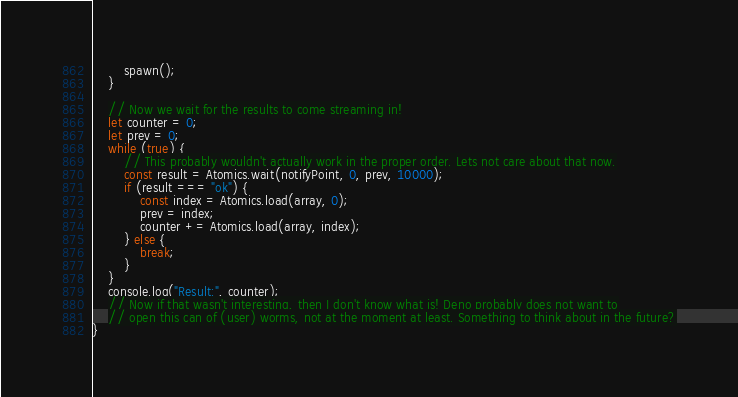Convert code to text. <code><loc_0><loc_0><loc_500><loc_500><_TypeScript_>        spawn();
    }

    // Now we wait for the results to come streaming in!
    let counter = 0;
    let prev = 0;
    while (true) {
        // This probably wouldn't actually work in the proper order. Lets not care about that now.
        const result = Atomics.wait(notifyPoint, 0, prev, 10000);
        if (result === "ok") {
            const index = Atomics.load(array, 0);
            prev = index;
            counter += Atomics.load(array, index);
        } else {
            break;
        }
    }
    console.log("Result:", counter);
    // Now if that wasn't interesting, then I don't know what is! Deno probably does not want to
    // open this can of (user) worms, not at the moment at least. Something to think about in the future?
}</code> 